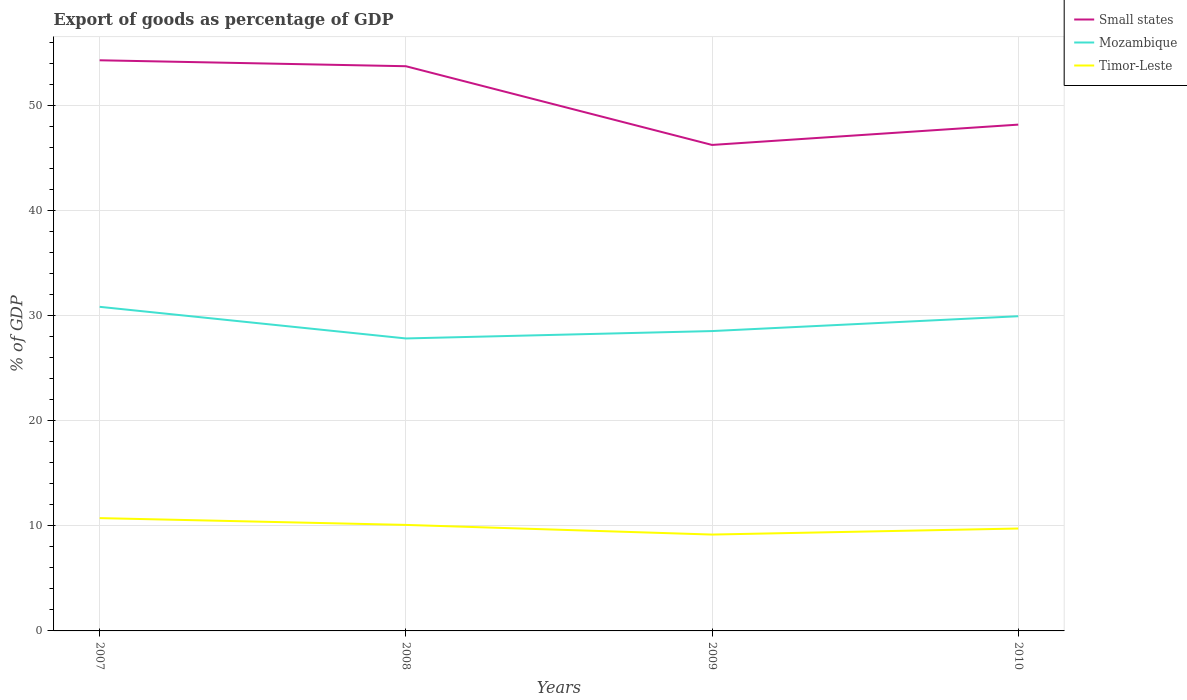Is the number of lines equal to the number of legend labels?
Offer a very short reply. Yes. Across all years, what is the maximum export of goods as percentage of GDP in Small states?
Provide a succinct answer. 46.24. In which year was the export of goods as percentage of GDP in Timor-Leste maximum?
Provide a succinct answer. 2009. What is the total export of goods as percentage of GDP in Small states in the graph?
Provide a succinct answer. 0.56. What is the difference between the highest and the second highest export of goods as percentage of GDP in Timor-Leste?
Keep it short and to the point. 1.56. What is the difference between the highest and the lowest export of goods as percentage of GDP in Mozambique?
Your response must be concise. 2. What is the difference between two consecutive major ticks on the Y-axis?
Give a very brief answer. 10. Are the values on the major ticks of Y-axis written in scientific E-notation?
Your response must be concise. No. Does the graph contain grids?
Your response must be concise. Yes. How many legend labels are there?
Your answer should be compact. 3. What is the title of the graph?
Keep it short and to the point. Export of goods as percentage of GDP. Does "Zambia" appear as one of the legend labels in the graph?
Your response must be concise. No. What is the label or title of the Y-axis?
Provide a short and direct response. % of GDP. What is the % of GDP in Small states in 2007?
Keep it short and to the point. 54.29. What is the % of GDP in Mozambique in 2007?
Make the answer very short. 30.84. What is the % of GDP in Timor-Leste in 2007?
Provide a succinct answer. 10.73. What is the % of GDP of Small states in 2008?
Offer a very short reply. 53.73. What is the % of GDP in Mozambique in 2008?
Offer a terse response. 27.83. What is the % of GDP of Timor-Leste in 2008?
Provide a succinct answer. 10.09. What is the % of GDP in Small states in 2009?
Provide a succinct answer. 46.24. What is the % of GDP of Mozambique in 2009?
Your answer should be very brief. 28.53. What is the % of GDP of Timor-Leste in 2009?
Offer a very short reply. 9.17. What is the % of GDP in Small states in 2010?
Your answer should be very brief. 48.17. What is the % of GDP in Mozambique in 2010?
Offer a very short reply. 29.94. What is the % of GDP in Timor-Leste in 2010?
Make the answer very short. 9.74. Across all years, what is the maximum % of GDP in Small states?
Make the answer very short. 54.29. Across all years, what is the maximum % of GDP of Mozambique?
Provide a succinct answer. 30.84. Across all years, what is the maximum % of GDP of Timor-Leste?
Give a very brief answer. 10.73. Across all years, what is the minimum % of GDP of Small states?
Offer a terse response. 46.24. Across all years, what is the minimum % of GDP of Mozambique?
Your answer should be very brief. 27.83. Across all years, what is the minimum % of GDP in Timor-Leste?
Your response must be concise. 9.17. What is the total % of GDP in Small states in the graph?
Your answer should be compact. 202.44. What is the total % of GDP in Mozambique in the graph?
Provide a short and direct response. 117.14. What is the total % of GDP of Timor-Leste in the graph?
Give a very brief answer. 39.73. What is the difference between the % of GDP of Small states in 2007 and that in 2008?
Your answer should be very brief. 0.56. What is the difference between the % of GDP in Mozambique in 2007 and that in 2008?
Provide a succinct answer. 3.01. What is the difference between the % of GDP in Timor-Leste in 2007 and that in 2008?
Make the answer very short. 0.65. What is the difference between the % of GDP of Small states in 2007 and that in 2009?
Make the answer very short. 8.05. What is the difference between the % of GDP in Mozambique in 2007 and that in 2009?
Provide a succinct answer. 2.31. What is the difference between the % of GDP in Timor-Leste in 2007 and that in 2009?
Your answer should be very brief. 1.56. What is the difference between the % of GDP in Small states in 2007 and that in 2010?
Keep it short and to the point. 6.12. What is the difference between the % of GDP of Mozambique in 2007 and that in 2010?
Your answer should be very brief. 0.89. What is the difference between the % of GDP in Timor-Leste in 2007 and that in 2010?
Make the answer very short. 0.99. What is the difference between the % of GDP in Small states in 2008 and that in 2009?
Offer a terse response. 7.49. What is the difference between the % of GDP of Mozambique in 2008 and that in 2009?
Make the answer very short. -0.7. What is the difference between the % of GDP in Timor-Leste in 2008 and that in 2009?
Give a very brief answer. 0.92. What is the difference between the % of GDP in Small states in 2008 and that in 2010?
Your answer should be compact. 5.56. What is the difference between the % of GDP in Mozambique in 2008 and that in 2010?
Provide a short and direct response. -2.11. What is the difference between the % of GDP in Timor-Leste in 2008 and that in 2010?
Offer a terse response. 0.34. What is the difference between the % of GDP of Small states in 2009 and that in 2010?
Your response must be concise. -1.93. What is the difference between the % of GDP in Mozambique in 2009 and that in 2010?
Offer a very short reply. -1.41. What is the difference between the % of GDP of Timor-Leste in 2009 and that in 2010?
Your response must be concise. -0.57. What is the difference between the % of GDP in Small states in 2007 and the % of GDP in Mozambique in 2008?
Offer a very short reply. 26.47. What is the difference between the % of GDP in Small states in 2007 and the % of GDP in Timor-Leste in 2008?
Give a very brief answer. 44.21. What is the difference between the % of GDP of Mozambique in 2007 and the % of GDP of Timor-Leste in 2008?
Your answer should be compact. 20.75. What is the difference between the % of GDP of Small states in 2007 and the % of GDP of Mozambique in 2009?
Ensure brevity in your answer.  25.76. What is the difference between the % of GDP in Small states in 2007 and the % of GDP in Timor-Leste in 2009?
Provide a succinct answer. 45.13. What is the difference between the % of GDP of Mozambique in 2007 and the % of GDP of Timor-Leste in 2009?
Offer a very short reply. 21.67. What is the difference between the % of GDP of Small states in 2007 and the % of GDP of Mozambique in 2010?
Your answer should be compact. 24.35. What is the difference between the % of GDP in Small states in 2007 and the % of GDP in Timor-Leste in 2010?
Make the answer very short. 44.55. What is the difference between the % of GDP in Mozambique in 2007 and the % of GDP in Timor-Leste in 2010?
Your response must be concise. 21.09. What is the difference between the % of GDP of Small states in 2008 and the % of GDP of Mozambique in 2009?
Make the answer very short. 25.2. What is the difference between the % of GDP of Small states in 2008 and the % of GDP of Timor-Leste in 2009?
Provide a succinct answer. 44.56. What is the difference between the % of GDP of Mozambique in 2008 and the % of GDP of Timor-Leste in 2009?
Make the answer very short. 18.66. What is the difference between the % of GDP in Small states in 2008 and the % of GDP in Mozambique in 2010?
Provide a short and direct response. 23.79. What is the difference between the % of GDP of Small states in 2008 and the % of GDP of Timor-Leste in 2010?
Your response must be concise. 43.99. What is the difference between the % of GDP in Mozambique in 2008 and the % of GDP in Timor-Leste in 2010?
Ensure brevity in your answer.  18.09. What is the difference between the % of GDP in Small states in 2009 and the % of GDP in Mozambique in 2010?
Your response must be concise. 16.3. What is the difference between the % of GDP of Small states in 2009 and the % of GDP of Timor-Leste in 2010?
Provide a succinct answer. 36.5. What is the difference between the % of GDP of Mozambique in 2009 and the % of GDP of Timor-Leste in 2010?
Ensure brevity in your answer.  18.79. What is the average % of GDP in Small states per year?
Offer a terse response. 50.61. What is the average % of GDP in Mozambique per year?
Your response must be concise. 29.28. What is the average % of GDP in Timor-Leste per year?
Keep it short and to the point. 9.93. In the year 2007, what is the difference between the % of GDP of Small states and % of GDP of Mozambique?
Ensure brevity in your answer.  23.46. In the year 2007, what is the difference between the % of GDP in Small states and % of GDP in Timor-Leste?
Your answer should be compact. 43.56. In the year 2007, what is the difference between the % of GDP in Mozambique and % of GDP in Timor-Leste?
Offer a terse response. 20.1. In the year 2008, what is the difference between the % of GDP of Small states and % of GDP of Mozambique?
Offer a very short reply. 25.9. In the year 2008, what is the difference between the % of GDP of Small states and % of GDP of Timor-Leste?
Your answer should be very brief. 43.64. In the year 2008, what is the difference between the % of GDP in Mozambique and % of GDP in Timor-Leste?
Ensure brevity in your answer.  17.74. In the year 2009, what is the difference between the % of GDP of Small states and % of GDP of Mozambique?
Provide a succinct answer. 17.71. In the year 2009, what is the difference between the % of GDP of Small states and % of GDP of Timor-Leste?
Offer a terse response. 37.07. In the year 2009, what is the difference between the % of GDP of Mozambique and % of GDP of Timor-Leste?
Your response must be concise. 19.36. In the year 2010, what is the difference between the % of GDP of Small states and % of GDP of Mozambique?
Your answer should be compact. 18.23. In the year 2010, what is the difference between the % of GDP of Small states and % of GDP of Timor-Leste?
Your answer should be compact. 38.43. In the year 2010, what is the difference between the % of GDP of Mozambique and % of GDP of Timor-Leste?
Your answer should be compact. 20.2. What is the ratio of the % of GDP of Small states in 2007 to that in 2008?
Ensure brevity in your answer.  1.01. What is the ratio of the % of GDP in Mozambique in 2007 to that in 2008?
Make the answer very short. 1.11. What is the ratio of the % of GDP of Timor-Leste in 2007 to that in 2008?
Your answer should be compact. 1.06. What is the ratio of the % of GDP in Small states in 2007 to that in 2009?
Ensure brevity in your answer.  1.17. What is the ratio of the % of GDP of Mozambique in 2007 to that in 2009?
Your response must be concise. 1.08. What is the ratio of the % of GDP of Timor-Leste in 2007 to that in 2009?
Ensure brevity in your answer.  1.17. What is the ratio of the % of GDP of Small states in 2007 to that in 2010?
Ensure brevity in your answer.  1.13. What is the ratio of the % of GDP of Mozambique in 2007 to that in 2010?
Offer a terse response. 1.03. What is the ratio of the % of GDP of Timor-Leste in 2007 to that in 2010?
Provide a succinct answer. 1.1. What is the ratio of the % of GDP in Small states in 2008 to that in 2009?
Keep it short and to the point. 1.16. What is the ratio of the % of GDP of Mozambique in 2008 to that in 2009?
Ensure brevity in your answer.  0.98. What is the ratio of the % of GDP of Timor-Leste in 2008 to that in 2009?
Keep it short and to the point. 1.1. What is the ratio of the % of GDP of Small states in 2008 to that in 2010?
Your answer should be compact. 1.12. What is the ratio of the % of GDP of Mozambique in 2008 to that in 2010?
Provide a succinct answer. 0.93. What is the ratio of the % of GDP of Timor-Leste in 2008 to that in 2010?
Ensure brevity in your answer.  1.04. What is the ratio of the % of GDP in Small states in 2009 to that in 2010?
Offer a terse response. 0.96. What is the ratio of the % of GDP of Mozambique in 2009 to that in 2010?
Provide a succinct answer. 0.95. What is the ratio of the % of GDP in Timor-Leste in 2009 to that in 2010?
Your answer should be compact. 0.94. What is the difference between the highest and the second highest % of GDP of Small states?
Make the answer very short. 0.56. What is the difference between the highest and the second highest % of GDP of Mozambique?
Your response must be concise. 0.89. What is the difference between the highest and the second highest % of GDP in Timor-Leste?
Offer a terse response. 0.65. What is the difference between the highest and the lowest % of GDP of Small states?
Your answer should be very brief. 8.05. What is the difference between the highest and the lowest % of GDP of Mozambique?
Offer a very short reply. 3.01. What is the difference between the highest and the lowest % of GDP in Timor-Leste?
Offer a very short reply. 1.56. 